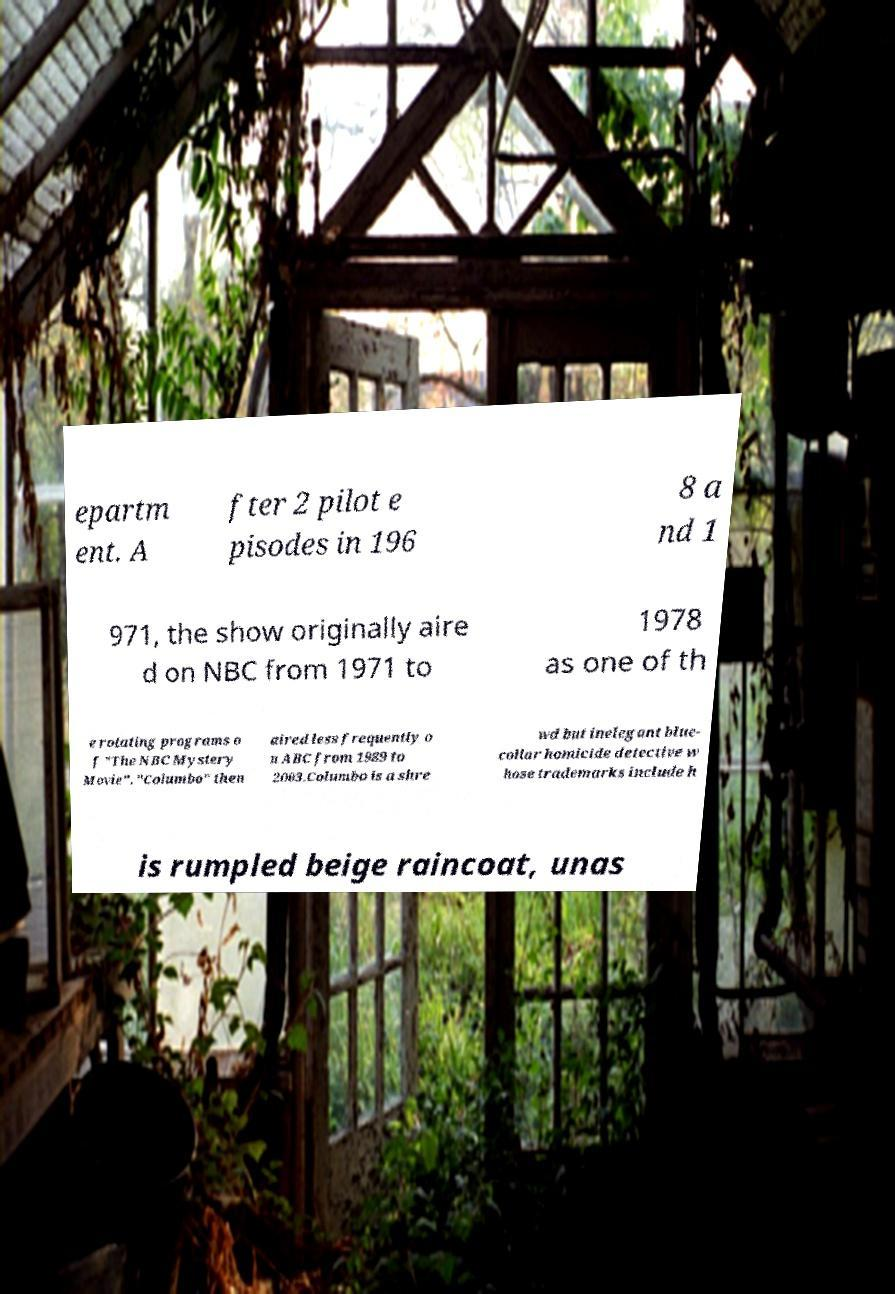For documentation purposes, I need the text within this image transcribed. Could you provide that? epartm ent. A fter 2 pilot e pisodes in 196 8 a nd 1 971, the show originally aire d on NBC from 1971 to 1978 as one of th e rotating programs o f "The NBC Mystery Movie". "Columbo" then aired less frequently o n ABC from 1989 to 2003.Columbo is a shre wd but inelegant blue- collar homicide detective w hose trademarks include h is rumpled beige raincoat, unas 